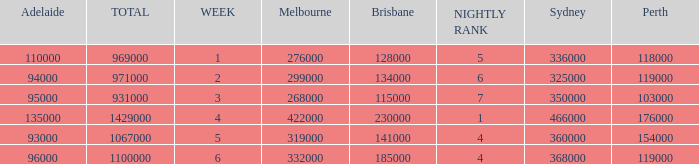What was the rating for Brisbane the week that Adelaide had 94000? 134000.0. 